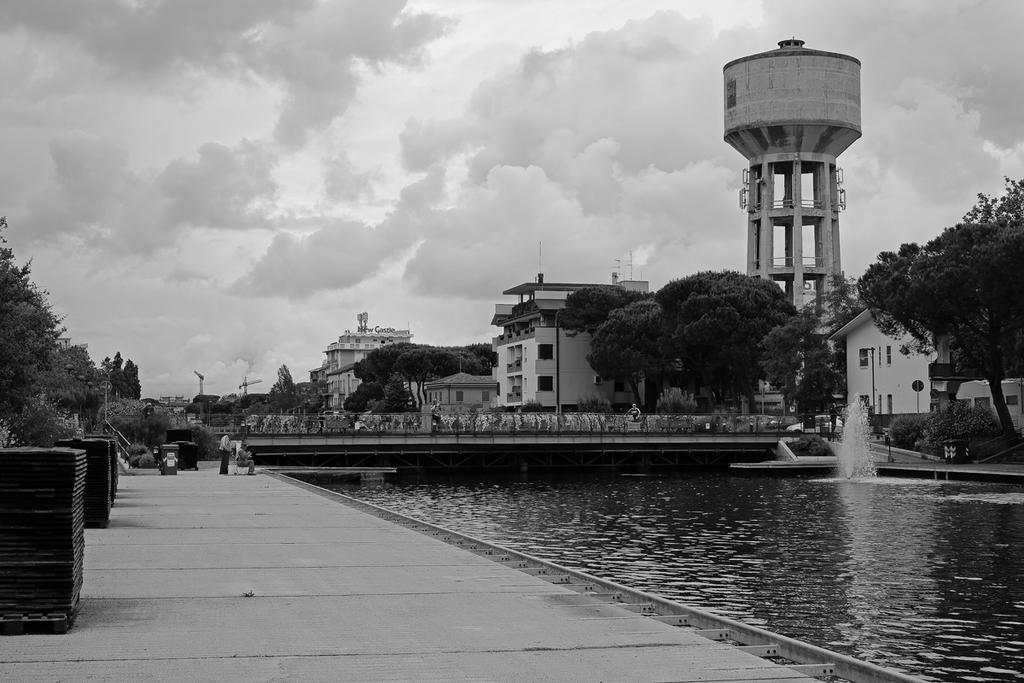How would you summarize this image in a sentence or two? To the left side of the image there is a footpath with few items on it. And to the left corner there are trees. And to the right bottom there is water. Above the water there is a bridge. And to the right side of the image there are trees and buildings with windows and roofs. And in the background there are many buildings, trees, poles and also there is a water tanker. And to the top of the image there is a sky with clouds. 